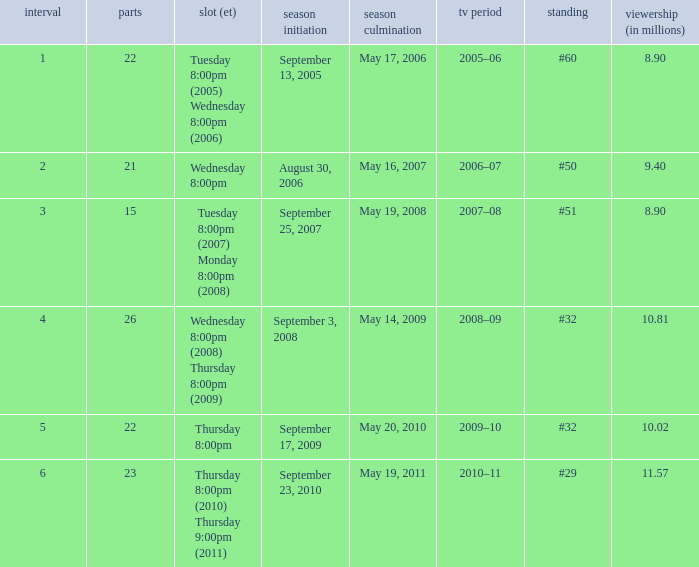How many seasons was the rank equal to #50? 1.0. 